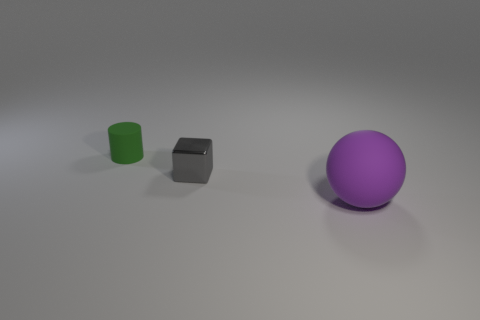Add 2 tiny rubber objects. How many objects exist? 5 Subtract all cylinders. How many objects are left? 2 Subtract all small gray cubes. Subtract all tiny gray shiny blocks. How many objects are left? 1 Add 1 matte balls. How many matte balls are left? 2 Add 1 big purple matte things. How many big purple matte things exist? 2 Subtract 1 purple spheres. How many objects are left? 2 